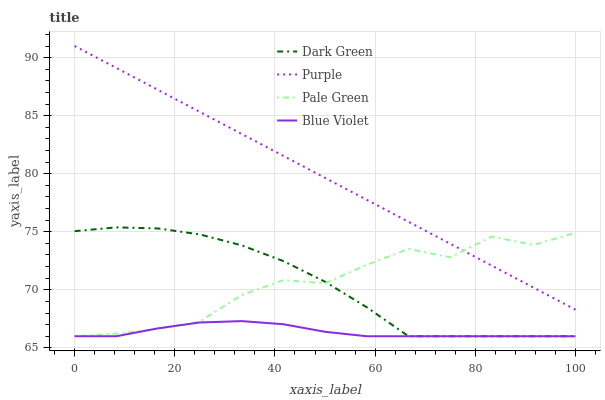Does Blue Violet have the minimum area under the curve?
Answer yes or no. Yes. Does Purple have the maximum area under the curve?
Answer yes or no. Yes. Does Pale Green have the minimum area under the curve?
Answer yes or no. No. Does Pale Green have the maximum area under the curve?
Answer yes or no. No. Is Purple the smoothest?
Answer yes or no. Yes. Is Pale Green the roughest?
Answer yes or no. Yes. Is Blue Violet the smoothest?
Answer yes or no. No. Is Blue Violet the roughest?
Answer yes or no. No. Does Pale Green have the lowest value?
Answer yes or no. Yes. Does Purple have the highest value?
Answer yes or no. Yes. Does Pale Green have the highest value?
Answer yes or no. No. Is Dark Green less than Purple?
Answer yes or no. Yes. Is Purple greater than Dark Green?
Answer yes or no. Yes. Does Dark Green intersect Blue Violet?
Answer yes or no. Yes. Is Dark Green less than Blue Violet?
Answer yes or no. No. Is Dark Green greater than Blue Violet?
Answer yes or no. No. Does Dark Green intersect Purple?
Answer yes or no. No. 